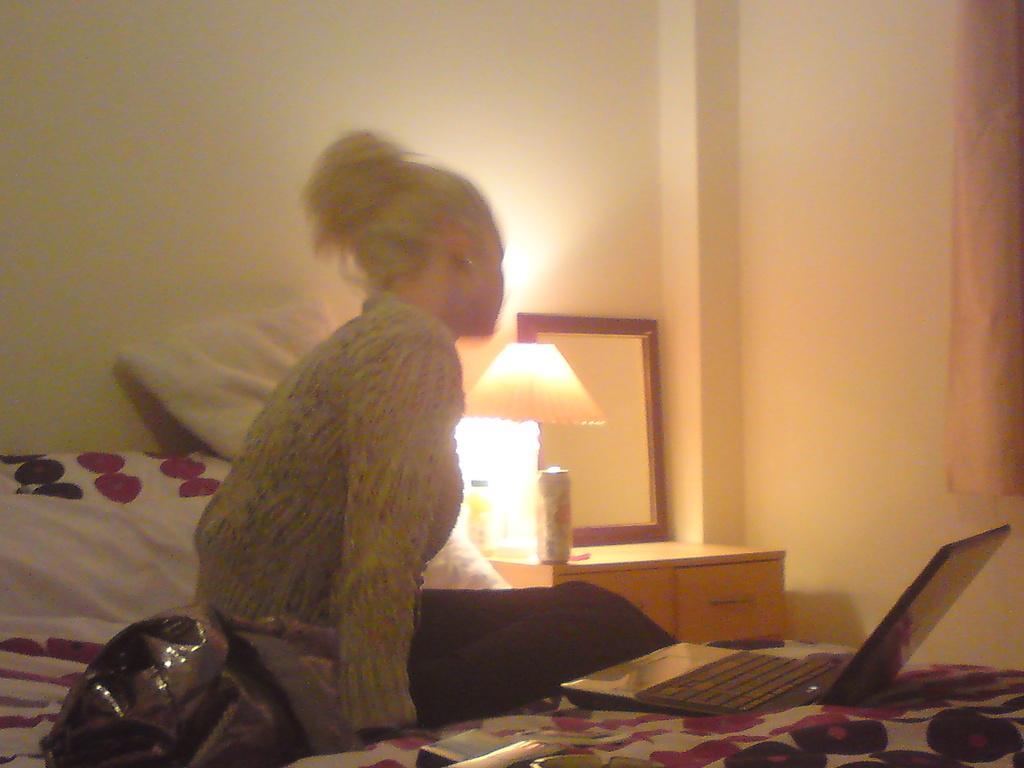Can you describe this image briefly? In this picture I can see there is a woman sitting on the bed and she is wearing a shirt. There is a laptop, carry bags and other objects placed on the bed and there is a table on to right and there is a mirror, light and a curtain on to right side and there is a wall in the backdrop. 